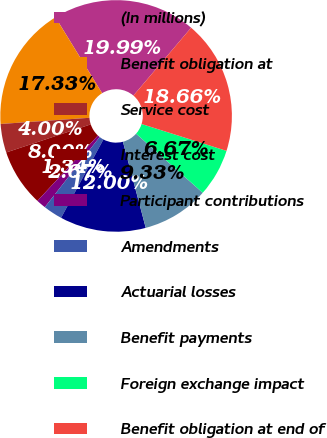Convert chart. <chart><loc_0><loc_0><loc_500><loc_500><pie_chart><fcel>(In millions)<fcel>Benefit obligation at<fcel>Service cost<fcel>Interest cost<fcel>Participant contributions<fcel>Amendments<fcel>Actuarial losses<fcel>Benefit payments<fcel>Foreign exchange impact<fcel>Benefit obligation at end of<nl><fcel>19.99%<fcel>17.33%<fcel>4.0%<fcel>8.0%<fcel>1.34%<fcel>2.67%<fcel>12.0%<fcel>9.33%<fcel>6.67%<fcel>18.66%<nl></chart> 